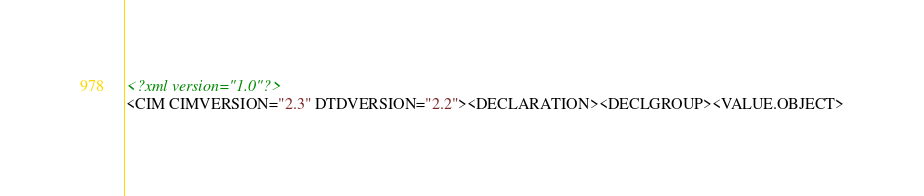Convert code to text. <code><loc_0><loc_0><loc_500><loc_500><_XML_><?xml version="1.0"?>
<CIM CIMVERSION="2.3" DTDVERSION="2.2"><DECLARATION><DECLGROUP><VALUE.OBJECT></code> 